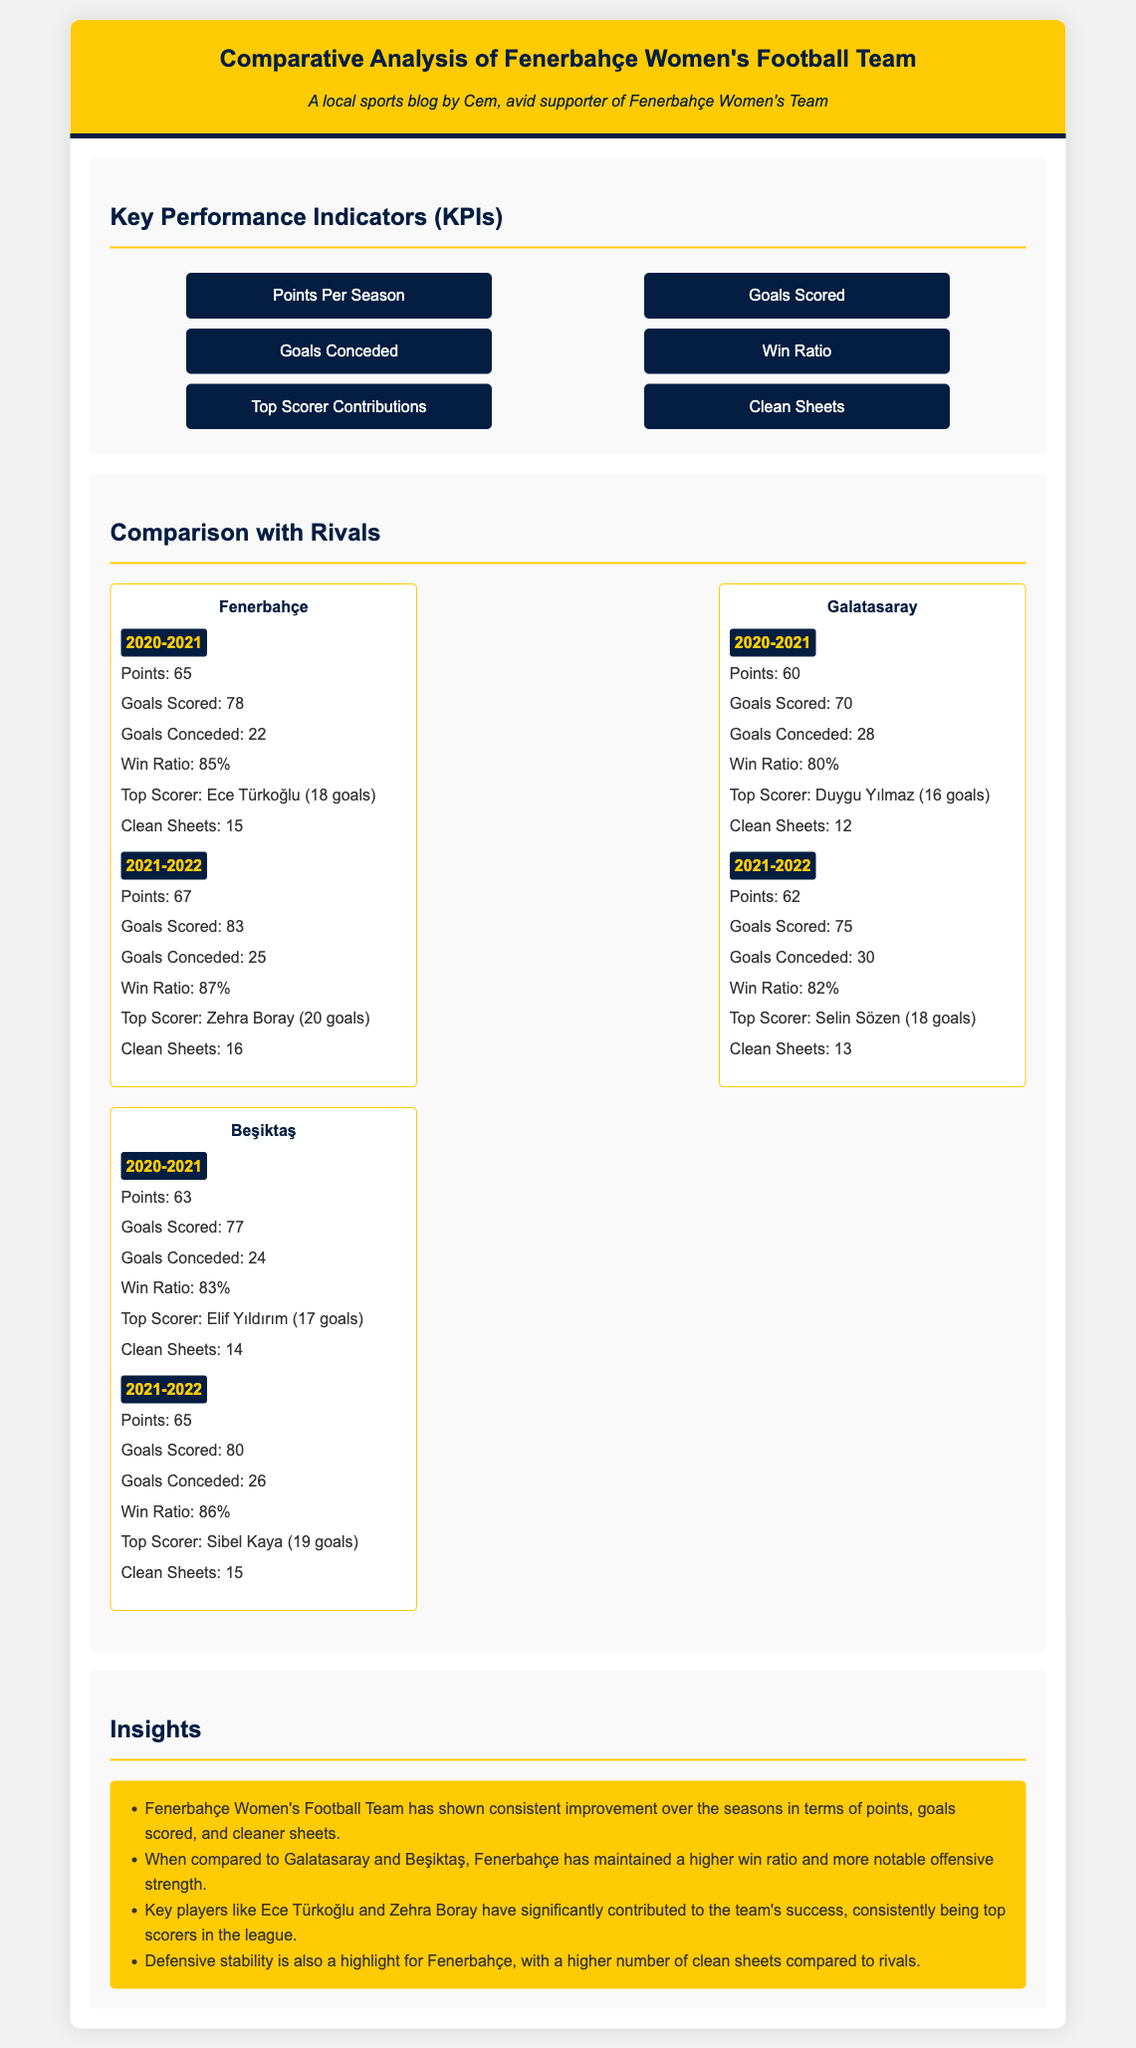What was Fenerbahçe's points total in the 2021-2022 season? Fenerbahçe's points total for the 2021-2022 season is explicitly stated in the document.
Answer: 67 Who was the top scorer for Fenerbahçe in the 2020-2021 season? The document specifically names the top scorer for Fenerbahçe in the mentioned season.
Answer: Ece Türkoğlu How many clean sheets did Galatasaray achieve in the 2021-2022 season? Galatasaray's clean sheets for the 2021-2022 season are detailed in the document.
Answer: 13 Which team had the highest win ratio in the 2021-2022 season? The win ratios for each team in the season are compared in the document to determine the highest.
Answer: Fenerbahçe What was the goals conceded by Beşiktaş in the 2020-2021 season? This statistic is listed for Beşiktaş in the provided season within the document.
Answer: 24 What is the trend observed in Fenerbahçe's points over the two seasons? The insights section reflects on the performance of Fenerbahçe over the seasons, including their points trend.
Answer: Consistent improvement How many goals were scored by the top scorer from Beşiktaş in the 2021-2022 season? The document specifies the goal contributions of Beşiktaş's top scorer for that season.
Answer: 19 Which team had more clean sheets, Fenerbahçe or Galatasaray, in the 2021-2022 season? The clean sheet statistics for both teams in the same season can be compared as referenced in the document.
Answer: Fenerbahçe What color is the background of the container in the document? The document describes the styling aspects, including the color of various elements.
Answer: White 